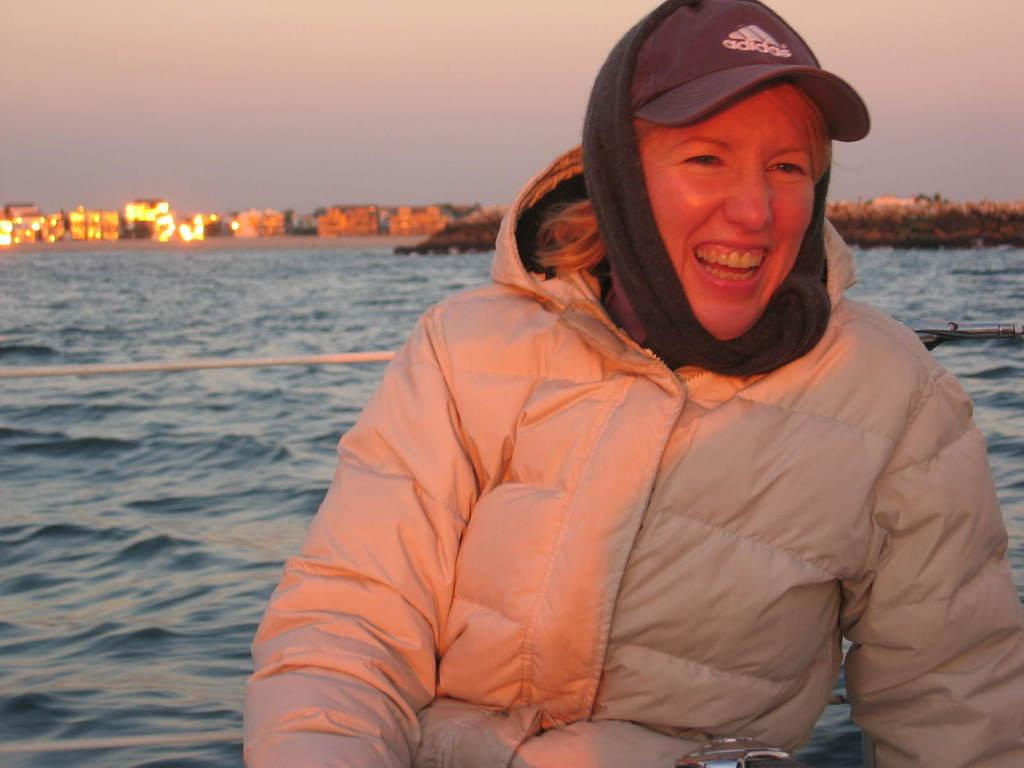What is the main subject of the image? There is a person in the image. What is the person wearing? The person is wearing a jacket and a cap. What is the person's facial expression? The person is smiling. What can be seen in the background of the image? There is water, buildings, trees, and the sky visible in the background of the image. What type of dirt can be seen on the person's shoes in the image? There is no dirt visible on the person's shoes in the image, as the person's feet are not shown. 